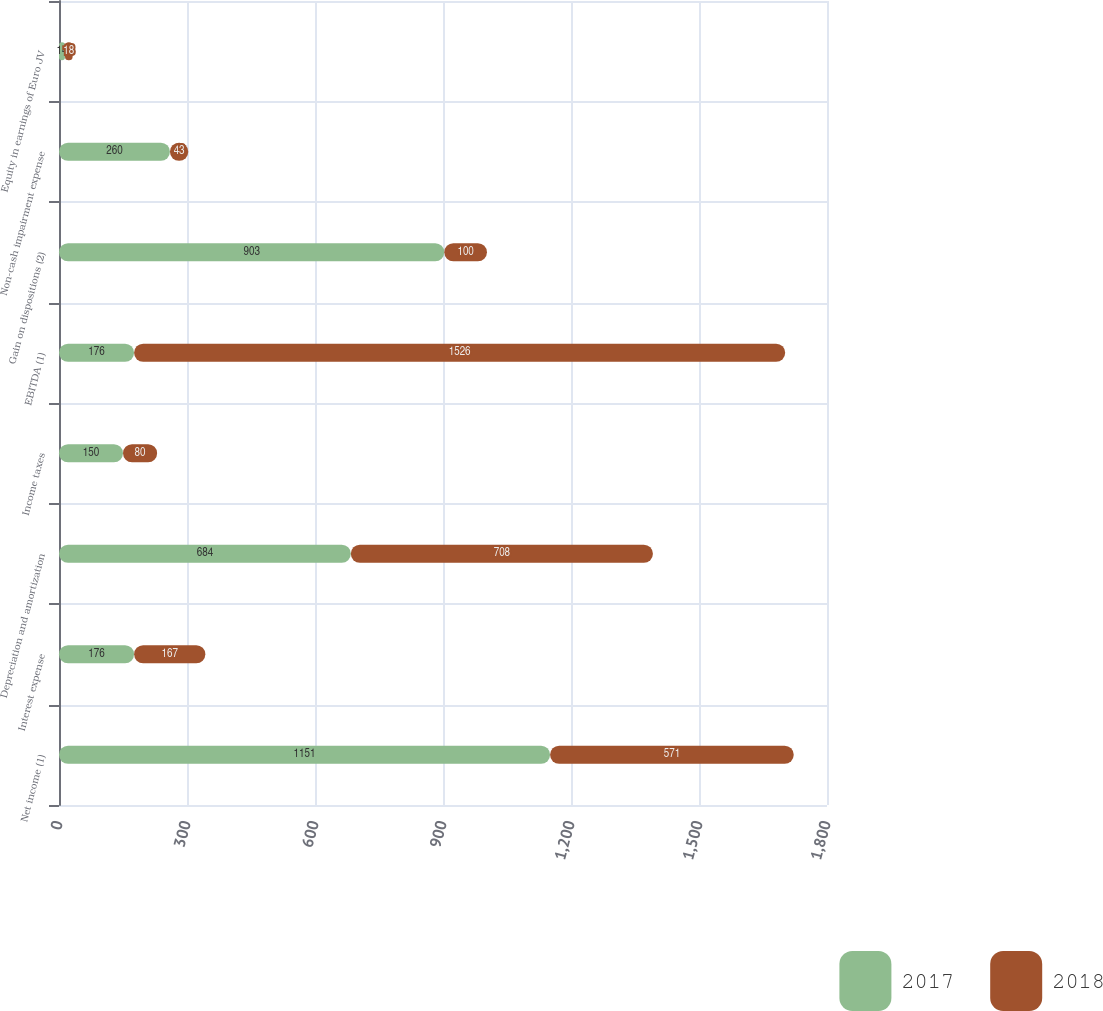Convert chart. <chart><loc_0><loc_0><loc_500><loc_500><stacked_bar_chart><ecel><fcel>Net income (1)<fcel>Interest expense<fcel>Depreciation and amortization<fcel>Income taxes<fcel>EBITDA (1)<fcel>Gain on dispositions (2)<fcel>Non-cash impairment expense<fcel>Equity in earnings of Euro JV<nl><fcel>2017<fcel>1151<fcel>176<fcel>684<fcel>150<fcel>176<fcel>903<fcel>260<fcel>14<nl><fcel>2018<fcel>571<fcel>167<fcel>708<fcel>80<fcel>1526<fcel>100<fcel>43<fcel>18<nl></chart> 